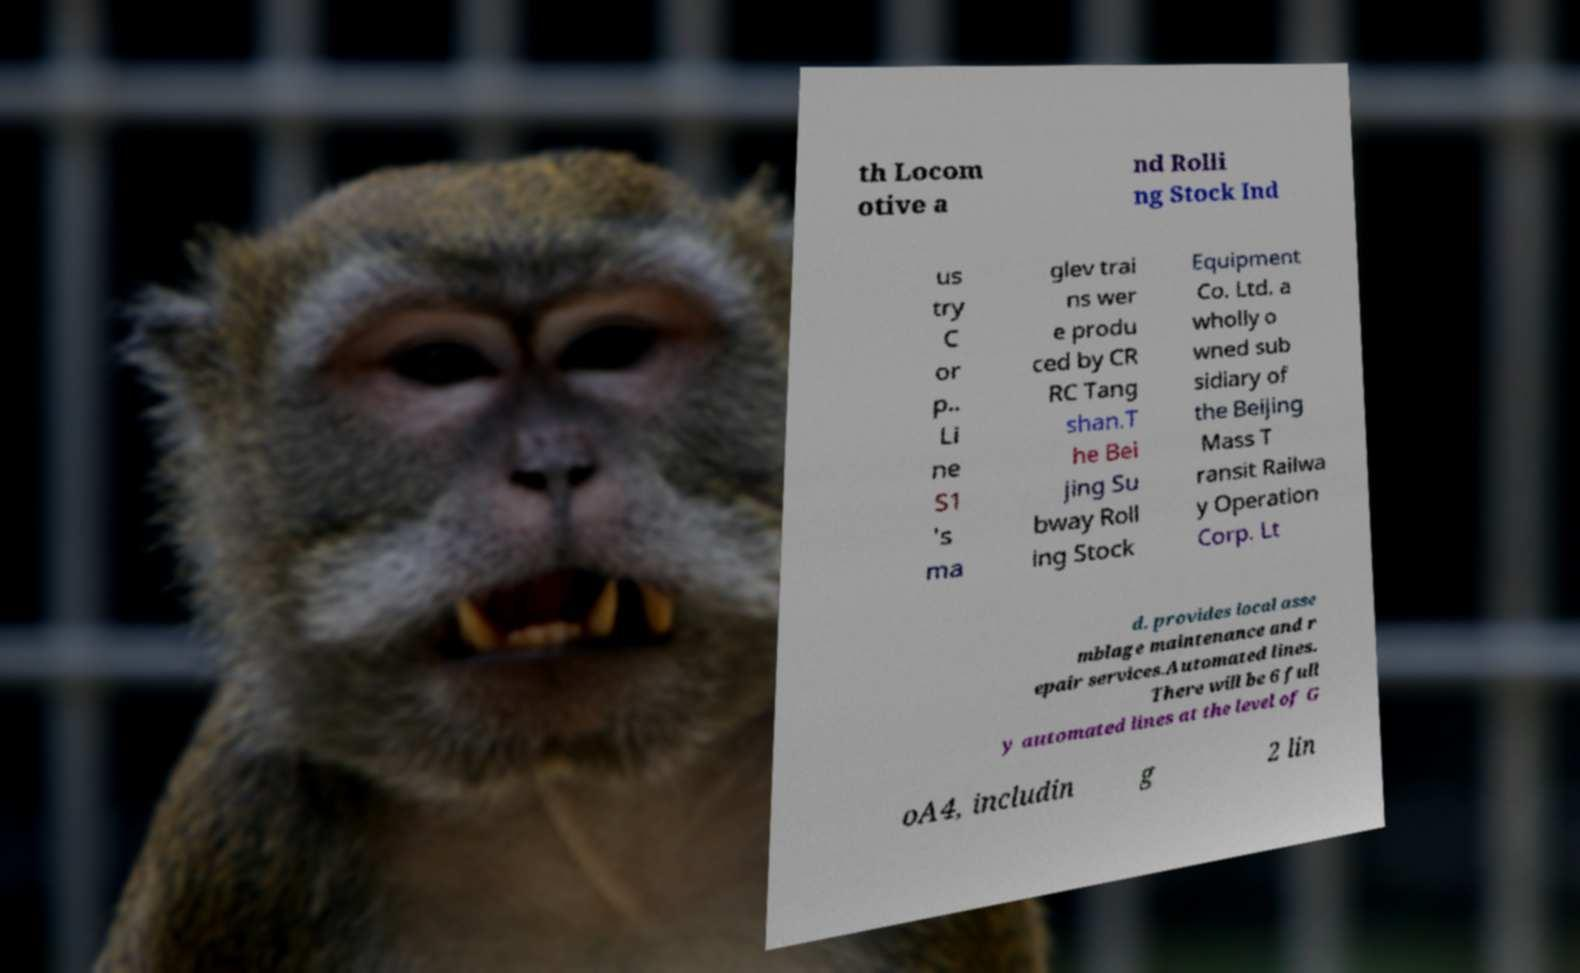Could you assist in decoding the text presented in this image and type it out clearly? th Locom otive a nd Rolli ng Stock Ind us try C or p.. Li ne S1 's ma glev trai ns wer e produ ced by CR RC Tang shan.T he Bei jing Su bway Roll ing Stock Equipment Co. Ltd. a wholly o wned sub sidiary of the Beijing Mass T ransit Railwa y Operation Corp. Lt d. provides local asse mblage maintenance and r epair services.Automated lines. There will be 6 full y automated lines at the level of G oA4, includin g 2 lin 